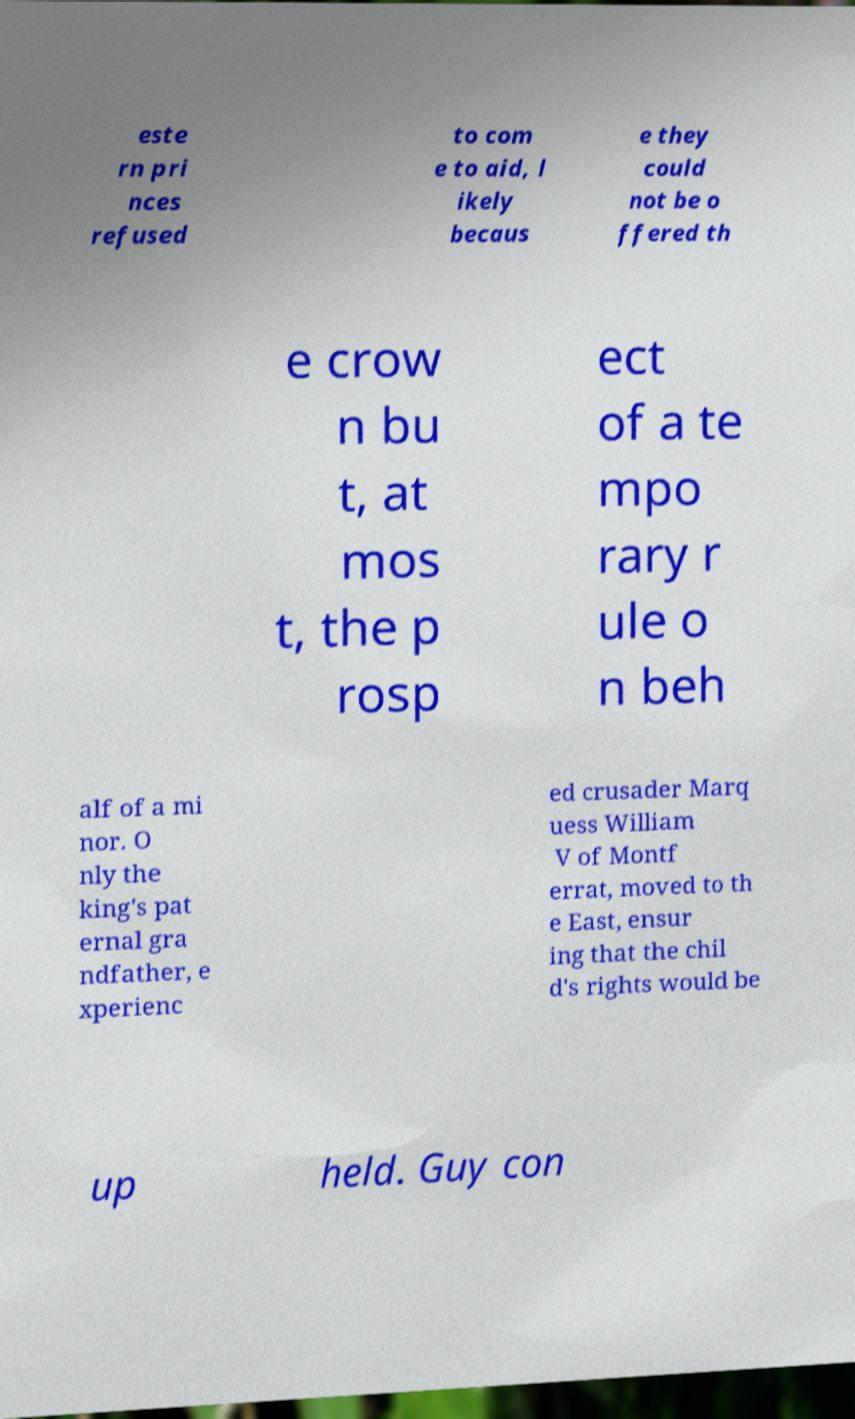Please identify and transcribe the text found in this image. este rn pri nces refused to com e to aid, l ikely becaus e they could not be o ffered th e crow n bu t, at mos t, the p rosp ect of a te mpo rary r ule o n beh alf of a mi nor. O nly the king's pat ernal gra ndfather, e xperienc ed crusader Marq uess William V of Montf errat, moved to th e East, ensur ing that the chil d's rights would be up held. Guy con 